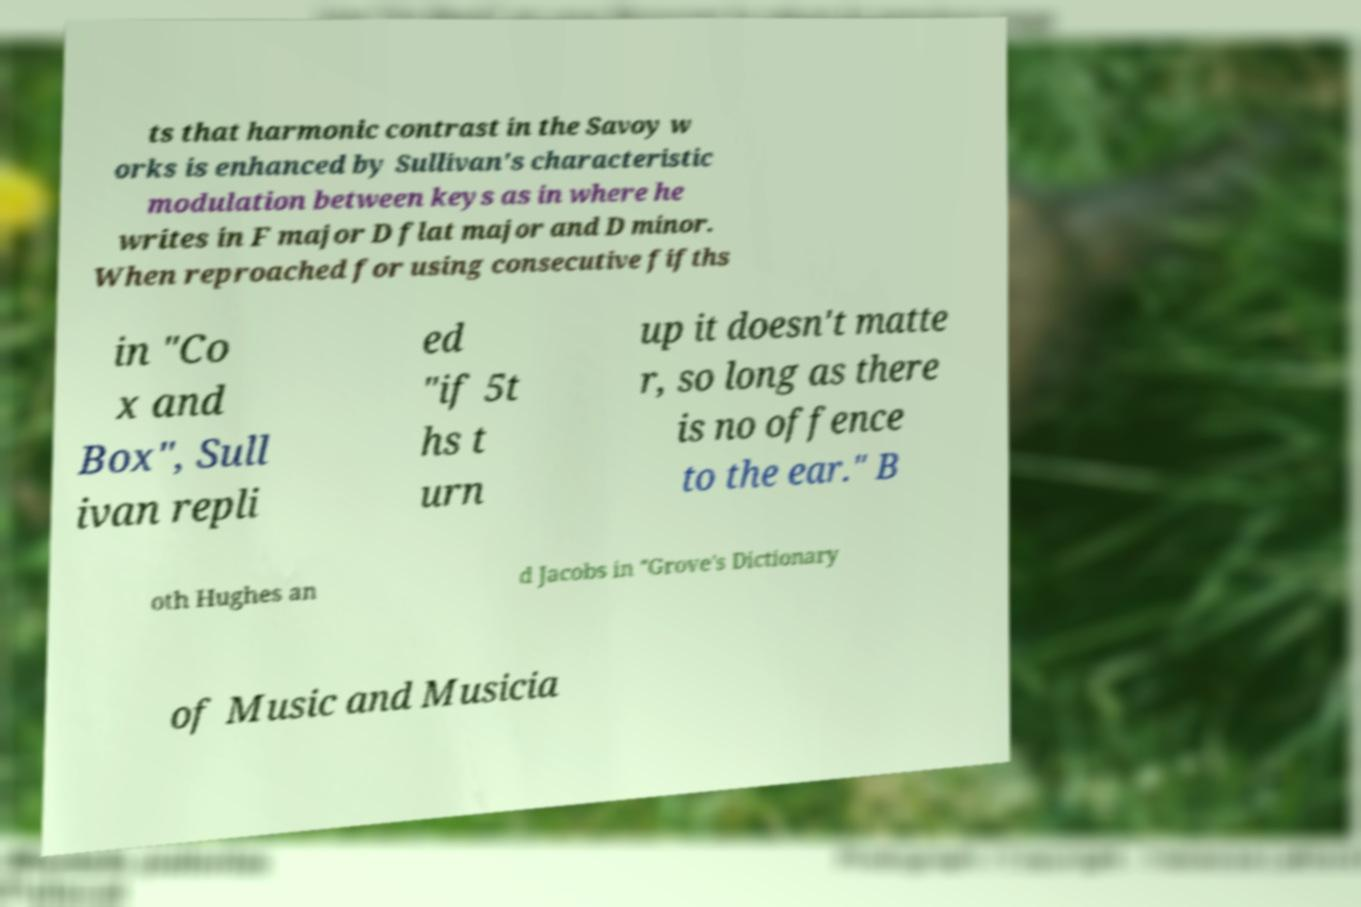Could you assist in decoding the text presented in this image and type it out clearly? ts that harmonic contrast in the Savoy w orks is enhanced by Sullivan's characteristic modulation between keys as in where he writes in F major D flat major and D minor. When reproached for using consecutive fifths in "Co x and Box", Sull ivan repli ed "if 5t hs t urn up it doesn't matte r, so long as there is no offence to the ear." B oth Hughes an d Jacobs in "Grove's Dictionary of Music and Musicia 